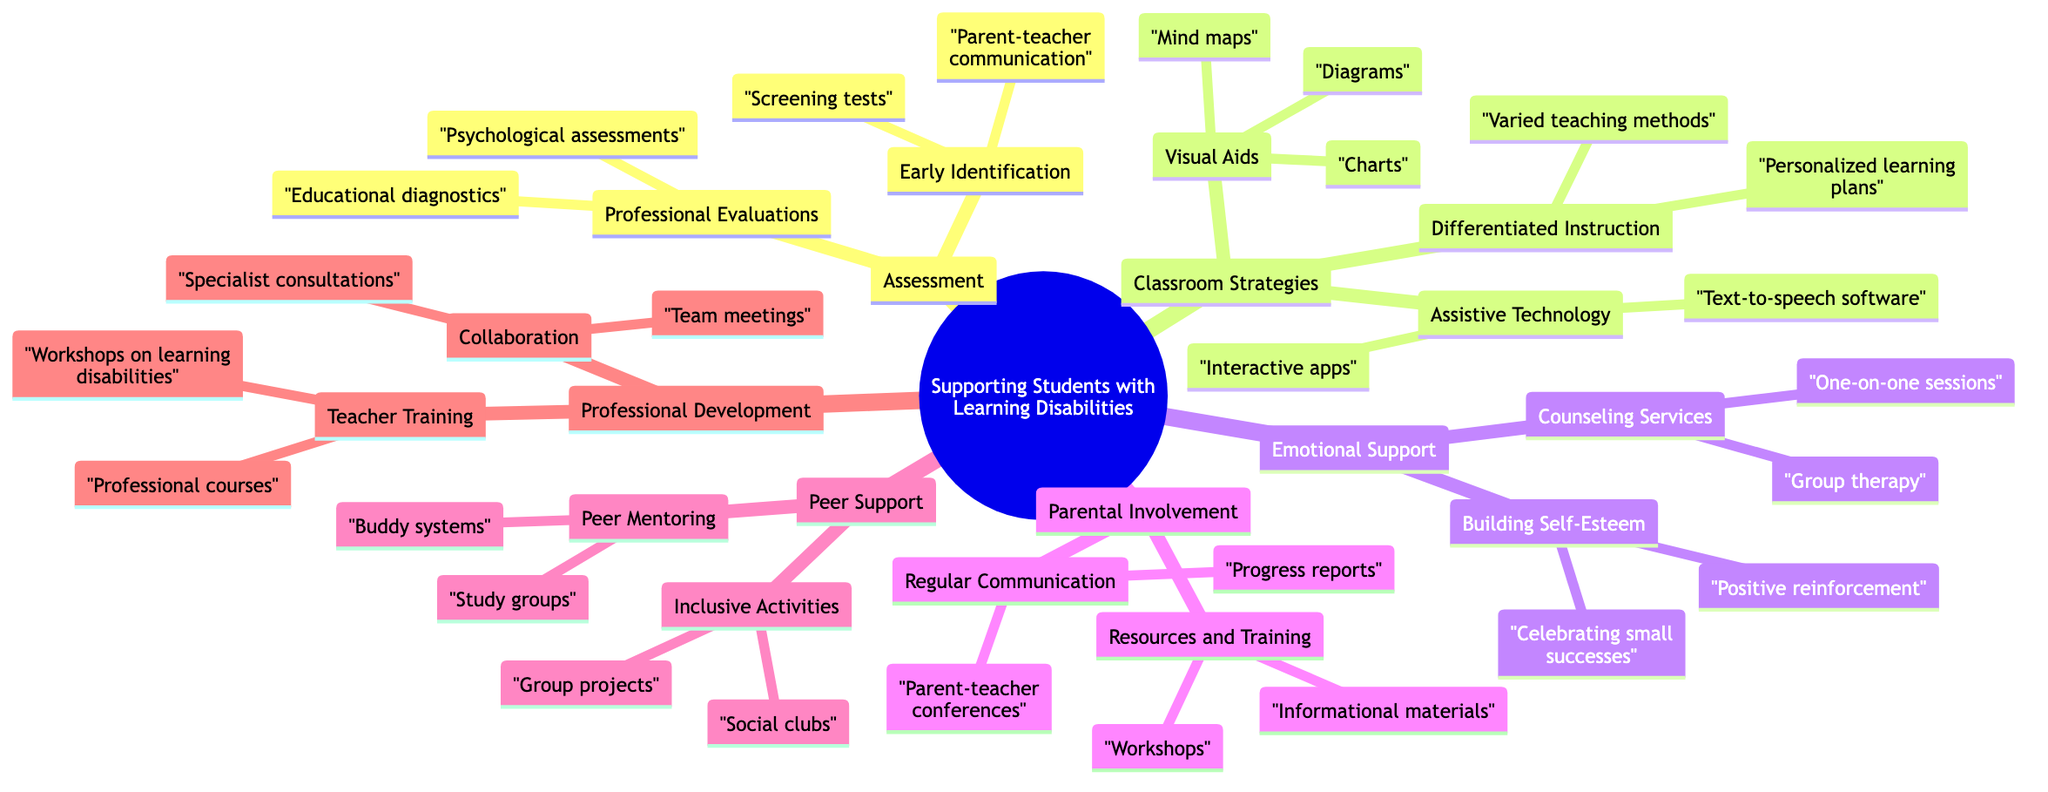What are the subcategories under Assessment? The main category 'Assessment' has two subcategories: 'Early Identification' and 'Professional Evaluations'. These are the first-level nodes directly connected to 'Assessment'.
Answer: Early Identification, Professional Evaluations How many classroom strategies are listed? The 'Classroom Strategies' category includes three subcategories: 'Differentiated Instruction', 'Assistive Technology', and 'Visual Aids'. By counting these three distinct elements, we find the quantity.
Answer: 3 What type of emotional support is mentioned? Under 'Emotional Support', two types are specified: 'Counseling Services' and 'Building Self-Esteem'. 'Counseling Services' contains further details, making them notable subcategories of emotional support.
Answer: Counseling Services, Building Self-Esteem What is included in Parental Involvement? The category 'Parental Involvement' consists of two subcategories: 'Regular Communication' and 'Resources and Training'. These are defining aspects found directly beneath this main category.
Answer: Regular Communication, Resources and Training Which assistive technology is referenced? Under 'Assistive Technology', two specific tools are listed: 'Text-to-speech software' and 'Interactive apps'. These are the detailed elements that explain what assistive technology can be used.
Answer: Text-to-speech software, Interactive apps What two types of peer support are described? The 'Peer Support' category has two component subcategories: 'Peer Mentoring' and 'Inclusive Activities'. Each of these subcategories details specific methods of peer support.
Answer: Peer Mentoring, Inclusive Activities What is the relationship between Professional Development and Teacher Training? 'Teacher Training' is a subcategory of 'Professional Development', establishing that it is one of the methods to support professional enhancement for teachers in the diagram.
Answer: Subcategory What is a method to build self-esteem in students? The 'Emotional Support' category specifies that 'Positive reinforcement' is a method used to build self-esteem. This phrase indicates a direct approach to emotional encouragement for students.
Answer: Positive reinforcement How does Differentiated Instruction assist students? Within 'Classroom Strategies', 'Differentiated Instruction' includes aspects like 'Personalized learning plans' and 'Varied teaching methods'. These methods enable tailored educational support for diverse learner needs.
Answer: Personalized learning plans, Varied teaching methods 